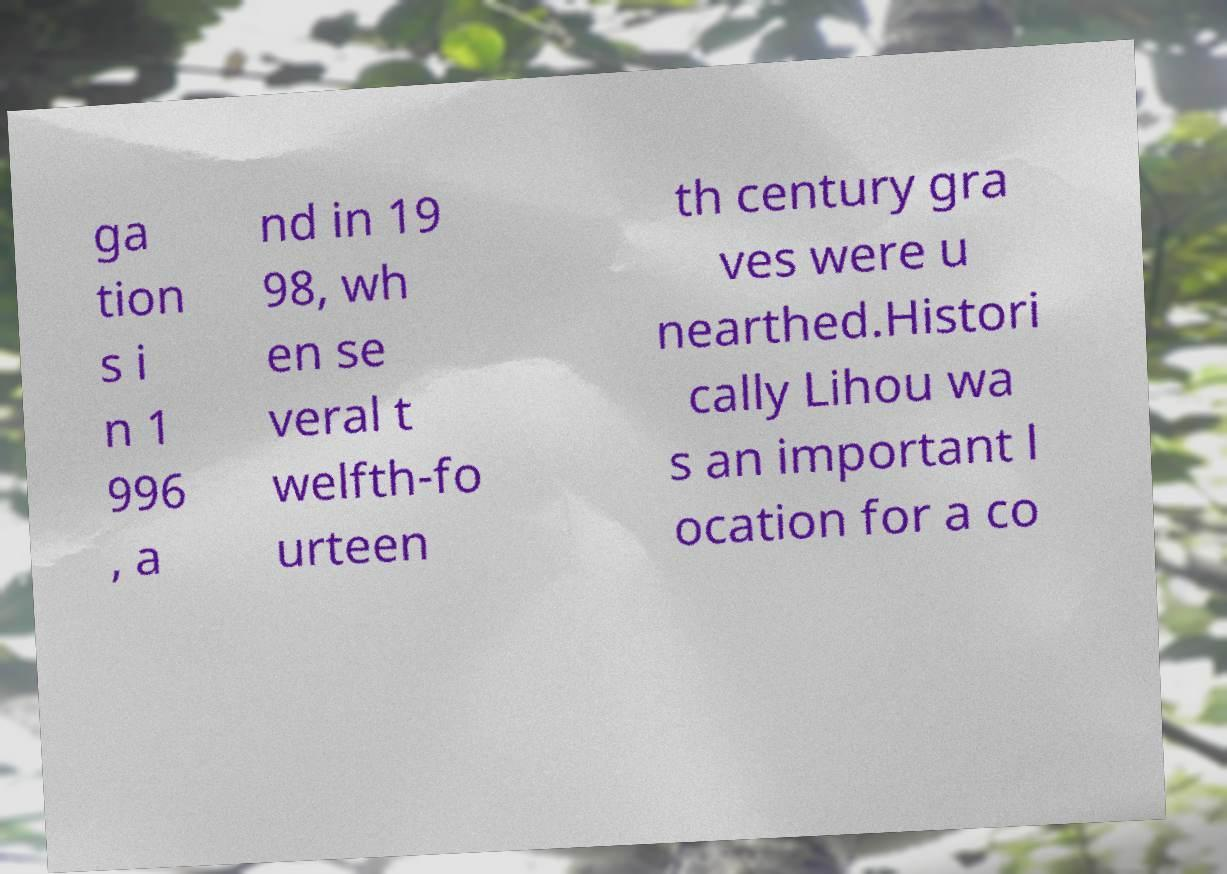Can you read and provide the text displayed in the image?This photo seems to have some interesting text. Can you extract and type it out for me? ga tion s i n 1 996 , a nd in 19 98, wh en se veral t welfth-fo urteen th century gra ves were u nearthed.Histori cally Lihou wa s an important l ocation for a co 